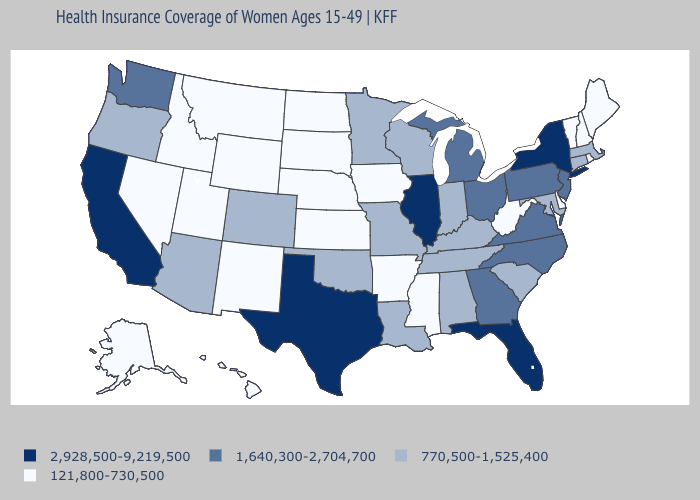What is the value of Minnesota?
Keep it brief. 770,500-1,525,400. What is the value of Virginia?
Write a very short answer. 1,640,300-2,704,700. Which states have the lowest value in the West?
Be succinct. Alaska, Hawaii, Idaho, Montana, Nevada, New Mexico, Utah, Wyoming. What is the value of New Jersey?
Answer briefly. 1,640,300-2,704,700. Name the states that have a value in the range 1,640,300-2,704,700?
Keep it brief. Georgia, Michigan, New Jersey, North Carolina, Ohio, Pennsylvania, Virginia, Washington. What is the value of Hawaii?
Be succinct. 121,800-730,500. Name the states that have a value in the range 2,928,500-9,219,500?
Write a very short answer. California, Florida, Illinois, New York, Texas. Does Missouri have the lowest value in the MidWest?
Short answer required. No. What is the highest value in the USA?
Concise answer only. 2,928,500-9,219,500. Does the first symbol in the legend represent the smallest category?
Write a very short answer. No. What is the value of Utah?
Be succinct. 121,800-730,500. What is the value of South Carolina?
Write a very short answer. 770,500-1,525,400. Does Illinois have the same value as Oklahoma?
Quick response, please. No. Which states have the lowest value in the USA?
Keep it brief. Alaska, Arkansas, Delaware, Hawaii, Idaho, Iowa, Kansas, Maine, Mississippi, Montana, Nebraska, Nevada, New Hampshire, New Mexico, North Dakota, Rhode Island, South Dakota, Utah, Vermont, West Virginia, Wyoming. 